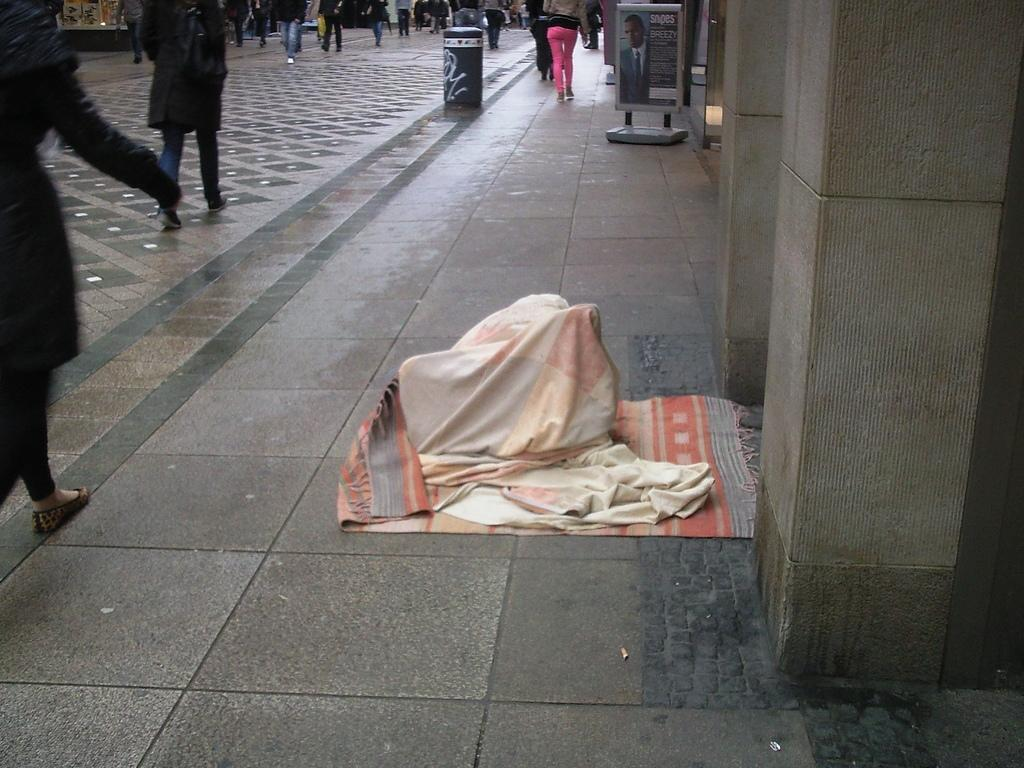Who or what can be seen in the image? There are people in the image. What object is visible in the image besides the people? There is a board in the image. What else is present in the image? Clothes are present in the image. What type of cannon is being used by the people in the image? There is no cannon present in the image. What authority figure is depicted in the image? The image does not show any authority figures. 